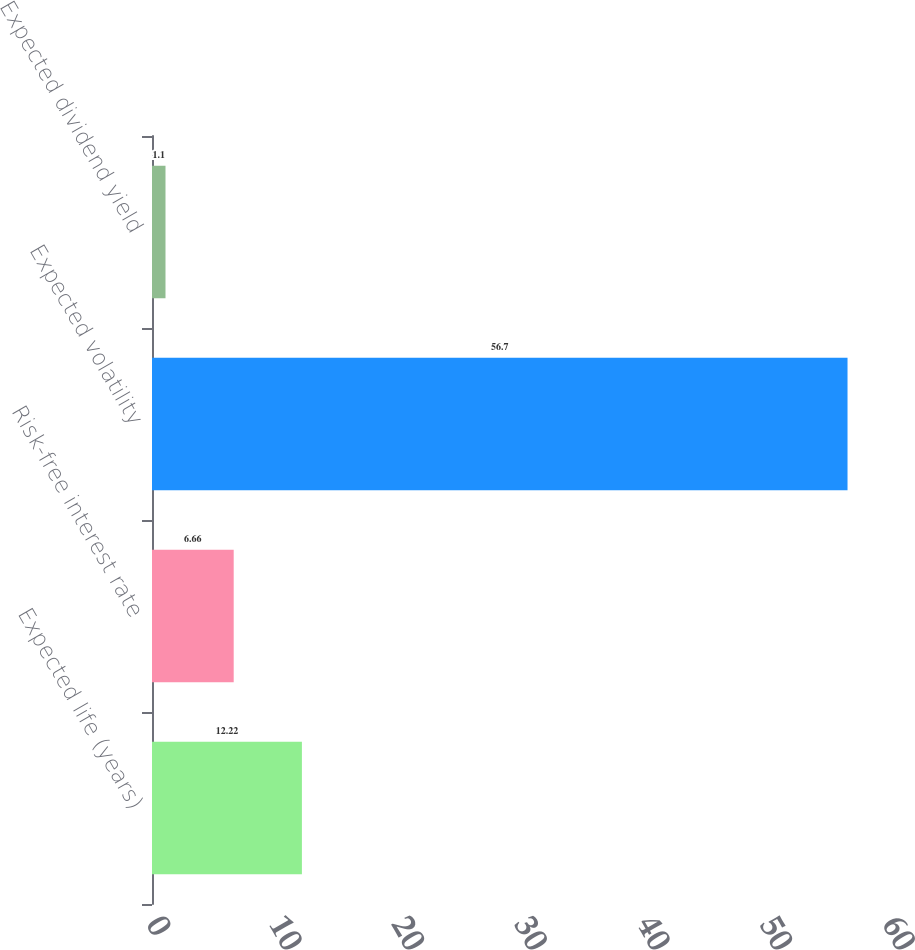<chart> <loc_0><loc_0><loc_500><loc_500><bar_chart><fcel>Expected life (years)<fcel>Risk-free interest rate<fcel>Expected volatility<fcel>Expected dividend yield<nl><fcel>12.22<fcel>6.66<fcel>56.7<fcel>1.1<nl></chart> 